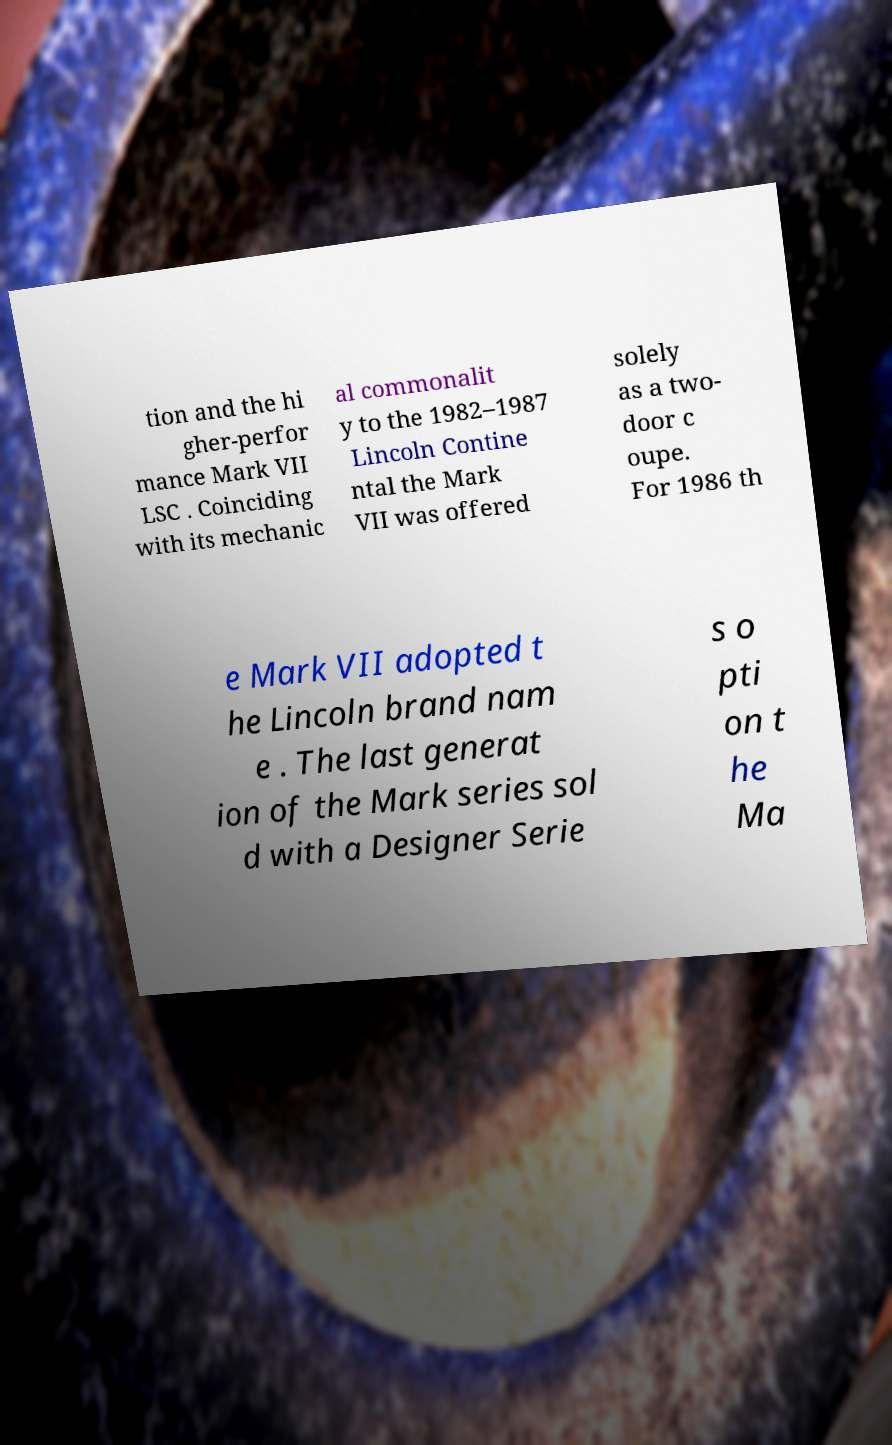Could you assist in decoding the text presented in this image and type it out clearly? tion and the hi gher-perfor mance Mark VII LSC . Coinciding with its mechanic al commonalit y to the 1982–1987 Lincoln Contine ntal the Mark VII was offered solely as a two- door c oupe. For 1986 th e Mark VII adopted t he Lincoln brand nam e . The last generat ion of the Mark series sol d with a Designer Serie s o pti on t he Ma 